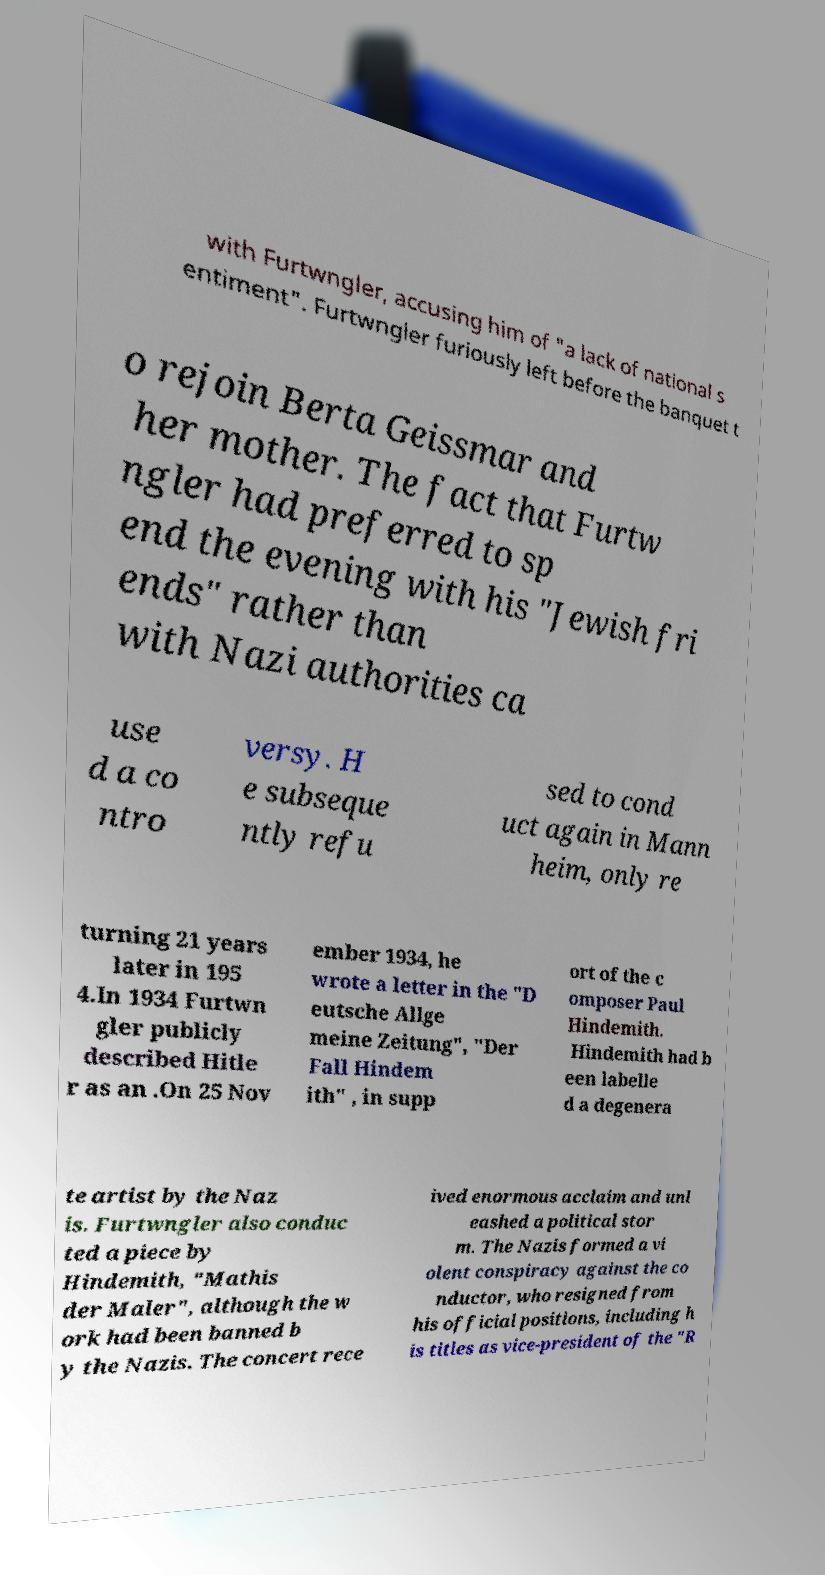Could you assist in decoding the text presented in this image and type it out clearly? with Furtwngler, accusing him of "a lack of national s entiment". Furtwngler furiously left before the banquet t o rejoin Berta Geissmar and her mother. The fact that Furtw ngler had preferred to sp end the evening with his "Jewish fri ends" rather than with Nazi authorities ca use d a co ntro versy. H e subseque ntly refu sed to cond uct again in Mann heim, only re turning 21 years later in 195 4.In 1934 Furtwn gler publicly described Hitle r as an .On 25 Nov ember 1934, he wrote a letter in the "D eutsche Allge meine Zeitung", "Der Fall Hindem ith" , in supp ort of the c omposer Paul Hindemith. Hindemith had b een labelle d a degenera te artist by the Naz is. Furtwngler also conduc ted a piece by Hindemith, "Mathis der Maler", although the w ork had been banned b y the Nazis. The concert rece ived enormous acclaim and unl eashed a political stor m. The Nazis formed a vi olent conspiracy against the co nductor, who resigned from his official positions, including h is titles as vice-president of the "R 